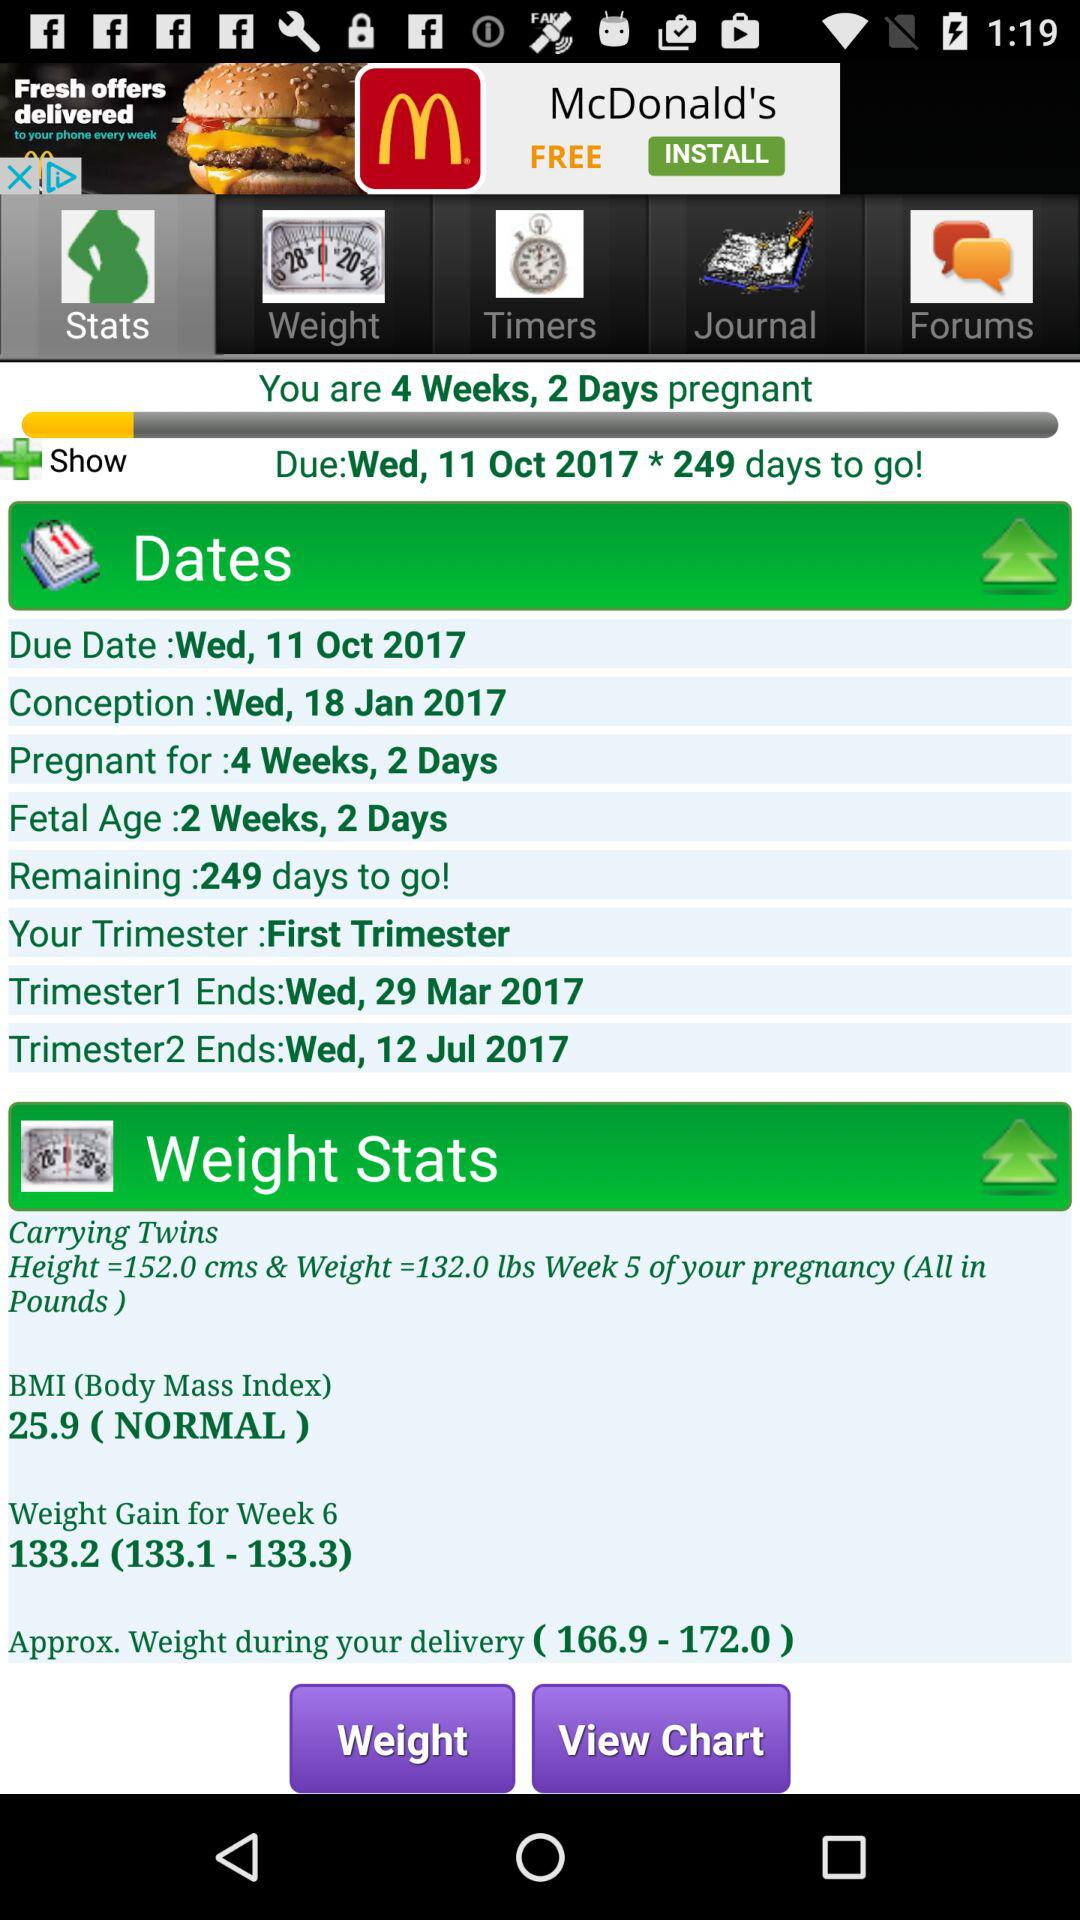When will "Trimester1" end? "Trimester1" will end on Wednesday, March 29, 2017. 